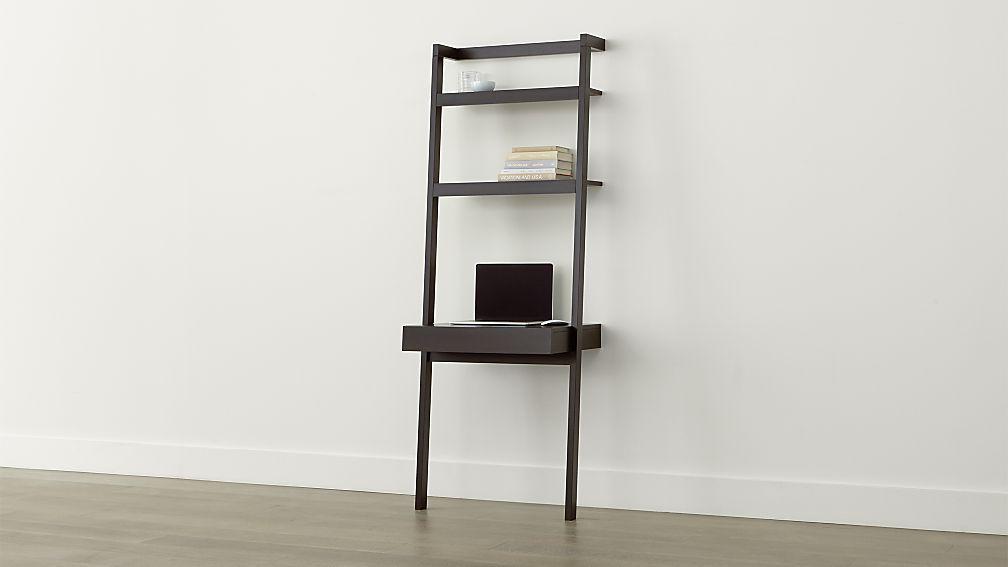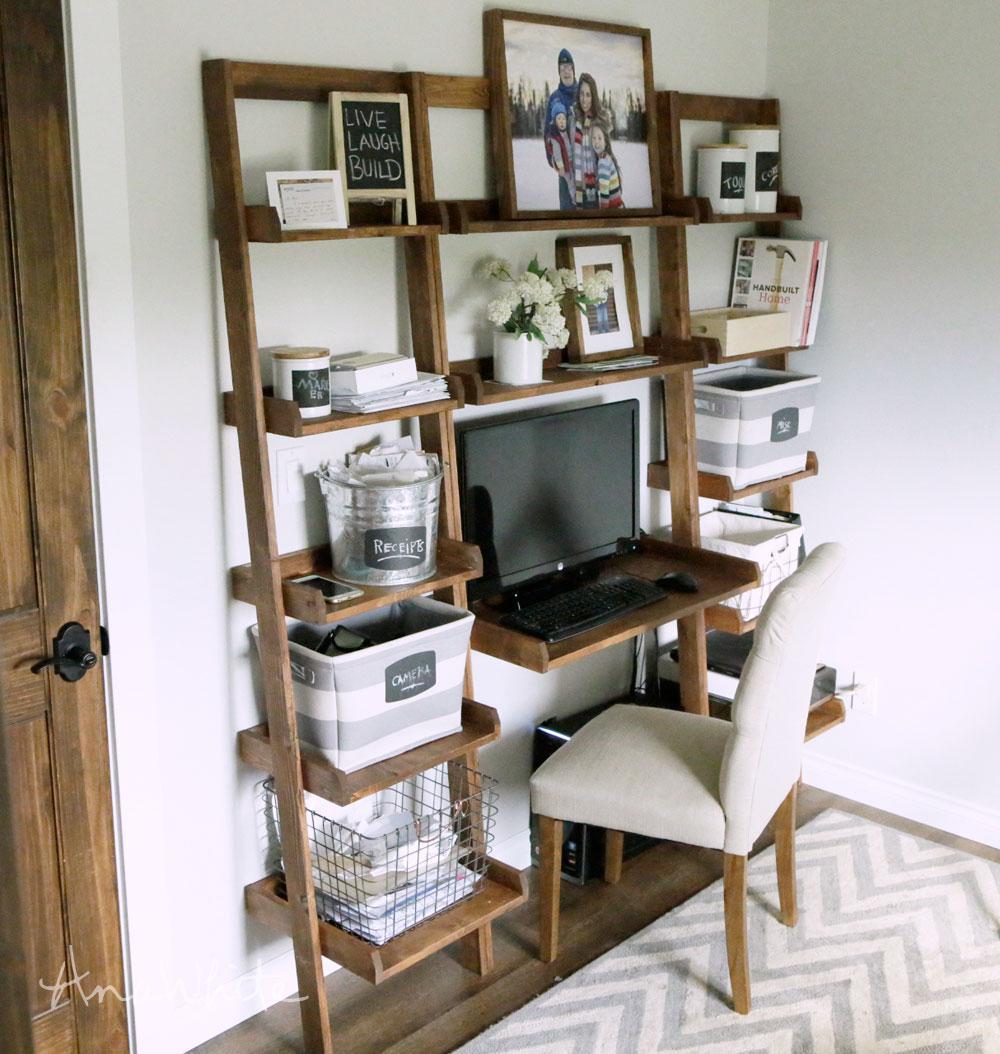The first image is the image on the left, the second image is the image on the right. For the images displayed, is the sentence "there is a herringbone striped rug in front of a wall desk with a white chair with wooden legs" factually correct? Answer yes or no. Yes. The first image is the image on the left, the second image is the image on the right. For the images shown, is this caption "A brown wooden book case sits up against the wall displaying many different items including a laptop." true? Answer yes or no. Yes. 